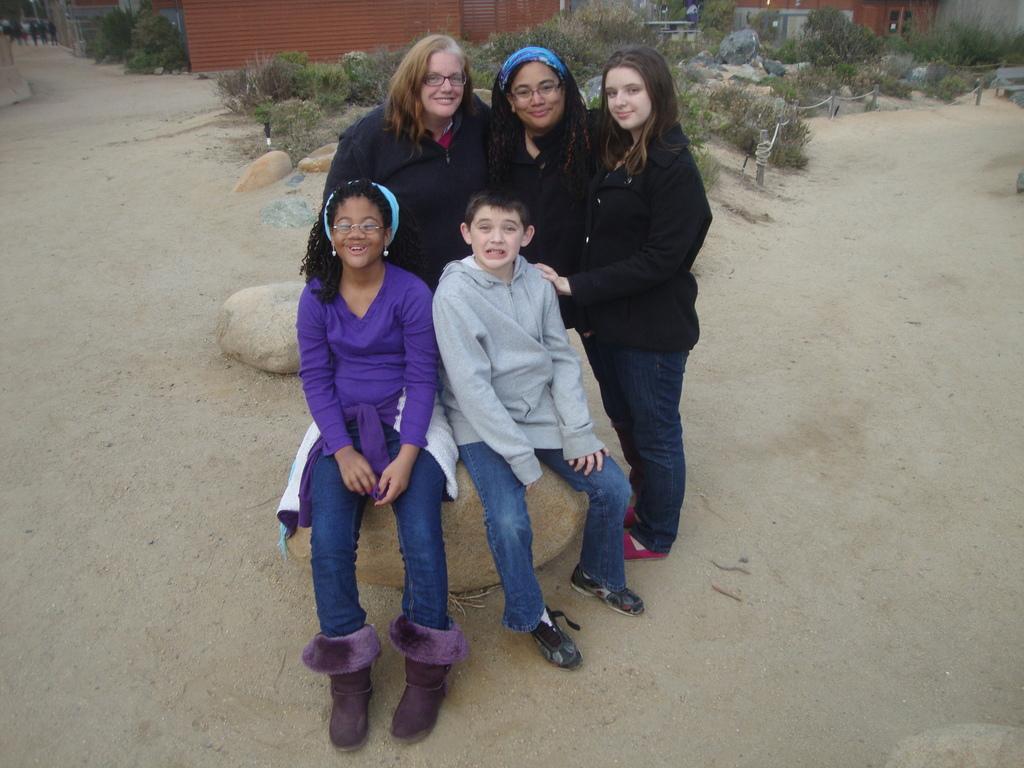Please provide a concise description of this image. In this image I can see few people, two childrens are sitting on the rocks, behind I can see some rocks, trees and houses. 